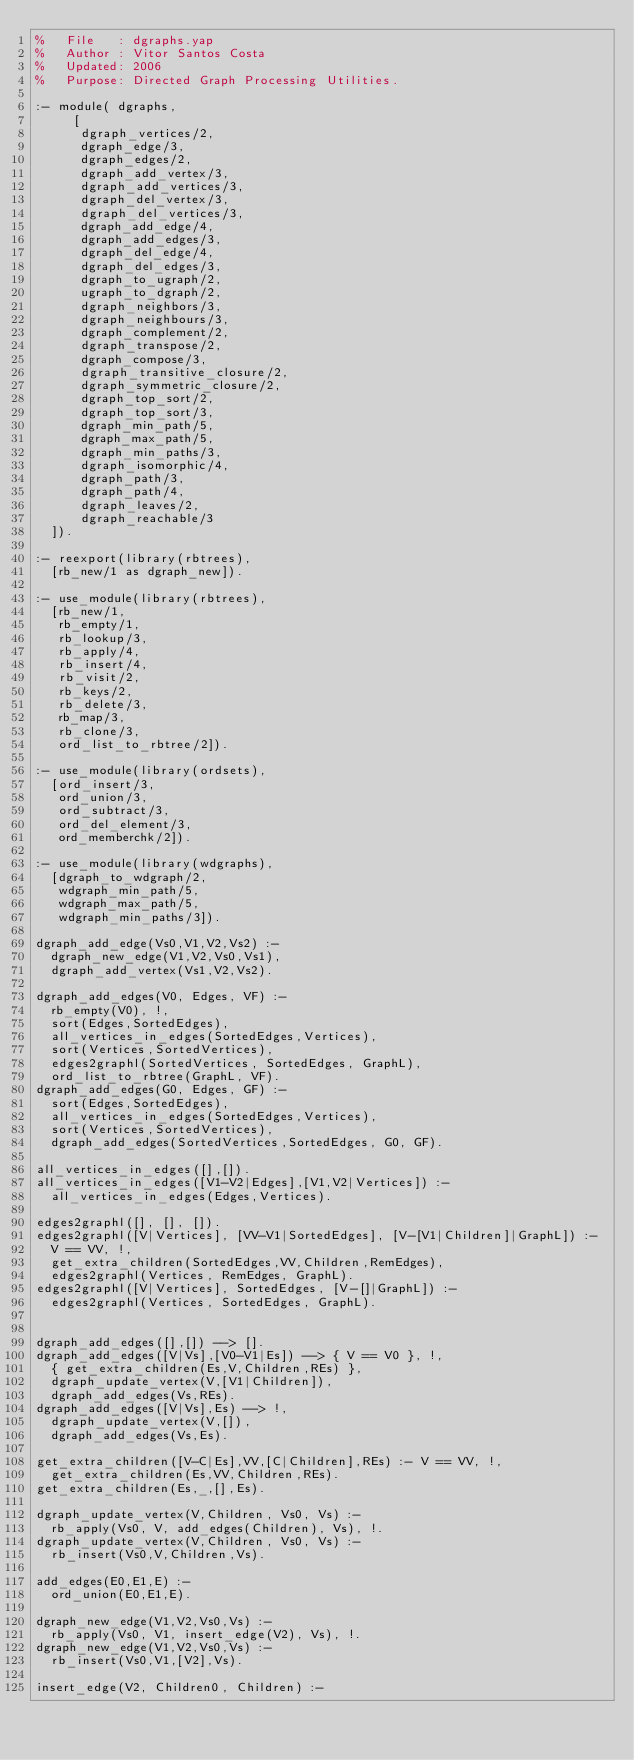<code> <loc_0><loc_0><loc_500><loc_500><_Prolog_>%   File   : dgraphs.yap
%   Author : Vitor Santos Costa
%   Updated: 2006
%   Purpose: Directed Graph Processing Utilities.

:- module( dgraphs,
	   [
	    dgraph_vertices/2,
	    dgraph_edge/3,
	    dgraph_edges/2,
	    dgraph_add_vertex/3,
	    dgraph_add_vertices/3,
	    dgraph_del_vertex/3,
	    dgraph_del_vertices/3,
	    dgraph_add_edge/4,
	    dgraph_add_edges/3,
	    dgraph_del_edge/4,
	    dgraph_del_edges/3,
	    dgraph_to_ugraph/2,
	    ugraph_to_dgraph/2,
	    dgraph_neighbors/3,
	    dgraph_neighbours/3,
	    dgraph_complement/2,
	    dgraph_transpose/2,
	    dgraph_compose/3,
	    dgraph_transitive_closure/2,
	    dgraph_symmetric_closure/2,
	    dgraph_top_sort/2,
	    dgraph_top_sort/3,
	    dgraph_min_path/5,
	    dgraph_max_path/5,
	    dgraph_min_paths/3,
	    dgraph_isomorphic/4,
	    dgraph_path/3,
	    dgraph_path/4,
	    dgraph_leaves/2,
	    dgraph_reachable/3
	]).

:- reexport(library(rbtrees),
	[rb_new/1 as dgraph_new]).

:- use_module(library(rbtrees),
	[rb_new/1,
	 rb_empty/1,
	 rb_lookup/3,
	 rb_apply/4,
	 rb_insert/4,
	 rb_visit/2,
	 rb_keys/2,
	 rb_delete/3,
	 rb_map/3,
	 rb_clone/3,
	 ord_list_to_rbtree/2]).

:- use_module(library(ordsets),
	[ord_insert/3,
	 ord_union/3,
	 ord_subtract/3,
	 ord_del_element/3,
	 ord_memberchk/2]).

:- use_module(library(wdgraphs),
	[dgraph_to_wdgraph/2,
	 wdgraph_min_path/5,
	 wdgraph_max_path/5,
	 wdgraph_min_paths/3]).

dgraph_add_edge(Vs0,V1,V2,Vs2) :-
	dgraph_new_edge(V1,V2,Vs0,Vs1),
	dgraph_add_vertex(Vs1,V2,Vs2).
	
dgraph_add_edges(V0, Edges, VF) :-
	rb_empty(V0), !,
	sort(Edges,SortedEdges),
	all_vertices_in_edges(SortedEdges,Vertices),
	sort(Vertices,SortedVertices),
	edges2graphl(SortedVertices, SortedEdges, GraphL),
	ord_list_to_rbtree(GraphL, VF).
dgraph_add_edges(G0, Edges, GF) :-
	sort(Edges,SortedEdges),
	all_vertices_in_edges(SortedEdges,Vertices),
	sort(Vertices,SortedVertices),
	dgraph_add_edges(SortedVertices,SortedEdges, G0, GF).

all_vertices_in_edges([],[]).
all_vertices_in_edges([V1-V2|Edges],[V1,V2|Vertices]) :-
	all_vertices_in_edges(Edges,Vertices).	 

edges2graphl([], [], []).
edges2graphl([V|Vertices], [VV-V1|SortedEdges], [V-[V1|Children]|GraphL]) :-
	V == VV, !,
	get_extra_children(SortedEdges,VV,Children,RemEdges),
	edges2graphl(Vertices, RemEdges, GraphL).
edges2graphl([V|Vertices], SortedEdges, [V-[]|GraphL]) :-
	edges2graphl(Vertices, SortedEdges, GraphL).


dgraph_add_edges([],[]) --> [].
dgraph_add_edges([V|Vs],[V0-V1|Es]) --> { V == V0 }, !,
	{ get_extra_children(Es,V,Children,REs) },
	dgraph_update_vertex(V,[V1|Children]),
	dgraph_add_edges(Vs,REs).
dgraph_add_edges([V|Vs],Es) --> !,
	dgraph_update_vertex(V,[]),
	dgraph_add_edges(Vs,Es).

get_extra_children([V-C|Es],VV,[C|Children],REs) :- V == VV, !,
	get_extra_children(Es,VV,Children,REs).
get_extra_children(Es,_,[],Es).

dgraph_update_vertex(V,Children, Vs0, Vs) :-
	rb_apply(Vs0, V, add_edges(Children), Vs), !.
dgraph_update_vertex(V,Children, Vs0, Vs) :-
	rb_insert(Vs0,V,Children,Vs).

add_edges(E0,E1,E) :-
	ord_union(E0,E1,E).

dgraph_new_edge(V1,V2,Vs0,Vs) :-
	rb_apply(Vs0, V1, insert_edge(V2), Vs), !.
dgraph_new_edge(V1,V2,Vs0,Vs) :-
	rb_insert(Vs0,V1,[V2],Vs).

insert_edge(V2, Children0, Children) :-</code> 